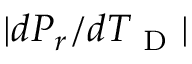<formula> <loc_0><loc_0><loc_500><loc_500>| d P _ { r } / d T _ { D } |</formula> 